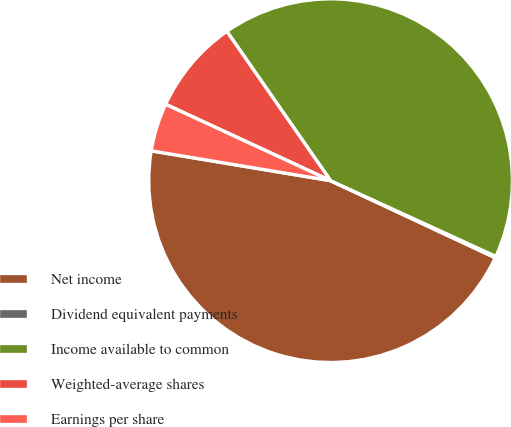Convert chart to OTSL. <chart><loc_0><loc_0><loc_500><loc_500><pie_chart><fcel>Net income<fcel>Dividend equivalent payments<fcel>Income available to common<fcel>Weighted-average shares<fcel>Earnings per share<nl><fcel>45.65%<fcel>0.13%<fcel>41.5%<fcel>8.43%<fcel>4.28%<nl></chart> 